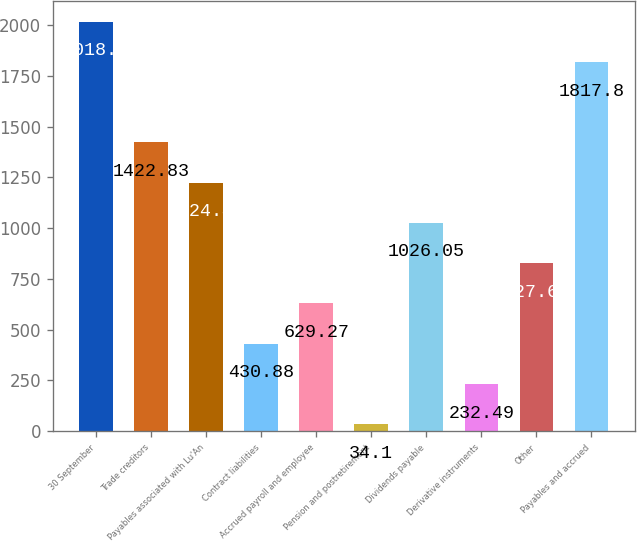Convert chart to OTSL. <chart><loc_0><loc_0><loc_500><loc_500><bar_chart><fcel>30 September<fcel>Trade creditors<fcel>Payables associated with Lu'An<fcel>Contract liabilities<fcel>Accrued payroll and employee<fcel>Pension and postretirement<fcel>Dividends payable<fcel>Derivative instruments<fcel>Other<fcel>Payables and accrued<nl><fcel>2018<fcel>1422.83<fcel>1224.44<fcel>430.88<fcel>629.27<fcel>34.1<fcel>1026.05<fcel>232.49<fcel>827.66<fcel>1817.8<nl></chart> 